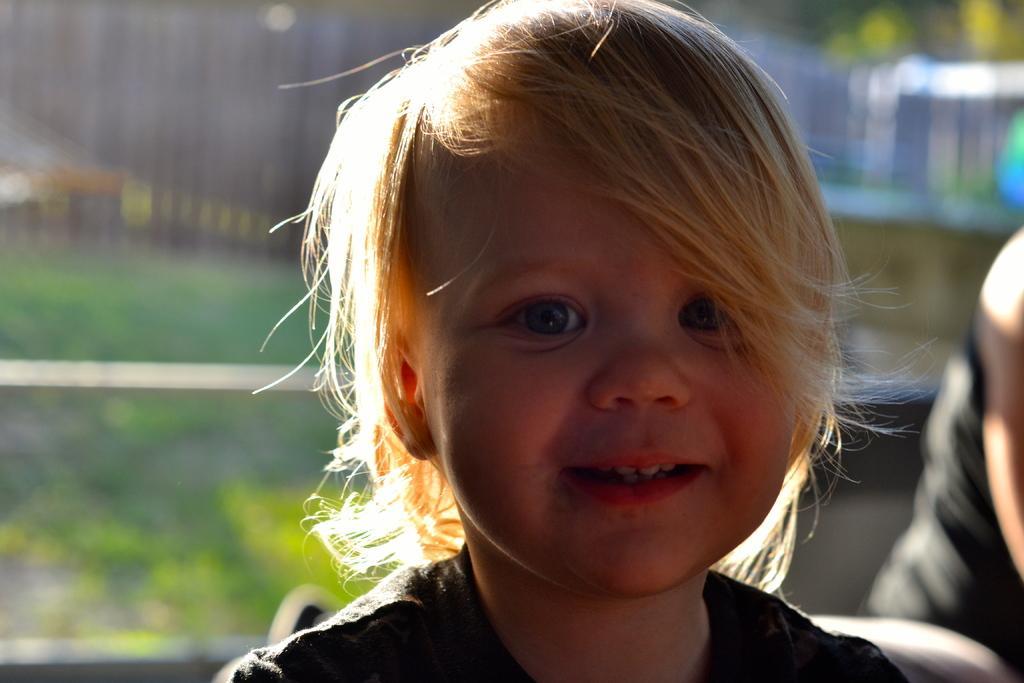Describe this image in one or two sentences. In the center of the image we can see a kid sitting and smiling. In the background we can see a person and a fence. 